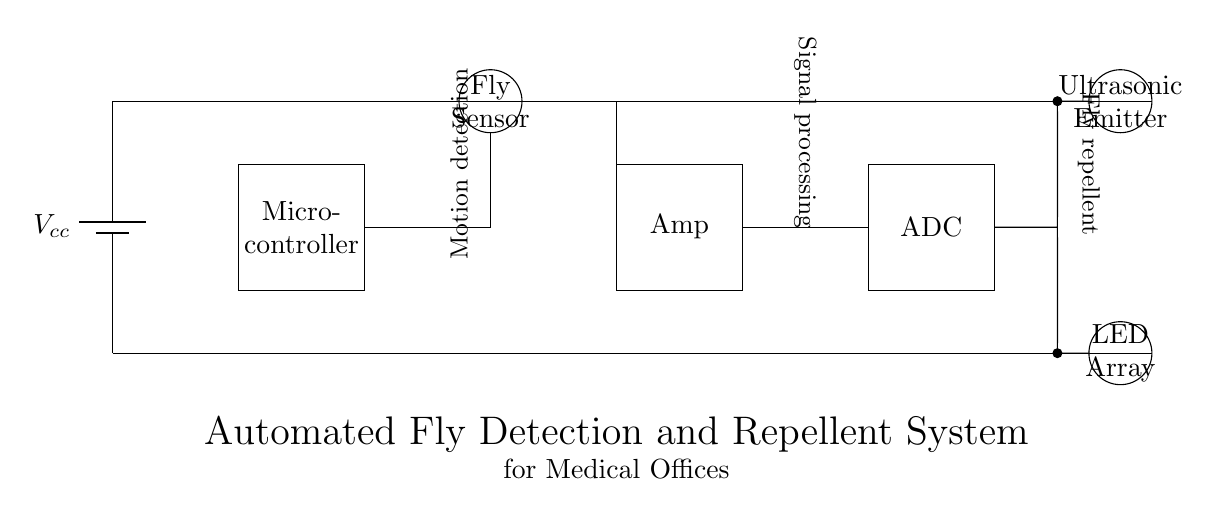What is the main component used for detecting flies? The main component for detecting flies is the Fly Sensor, which is indicated in the diagram with a circular shape. This component is specifically designed to identify the presence of flies, which is essential for the functioning of the system.
Answer: Fly Sensor What does the ADC stand for in this circuit? In this circuit, ADC stands for Analog-to-Digital Converter. It is represented in the diagram as a rectangular block labeled 'ADC' and is responsible for converting the analog signals from the amplifier into digital signals for processing.
Answer: Analog-to-Digital Converter How does the system repel flies? The system uses an Ultrasonic Emitter to repel flies, as indicated by its position in the diagram. The ultrasonic waves generated by this component are known to deter flies from the area.
Answer: Ultrasonic Emitter What type of signal processing is performed by the microcontroller? The microcontroller performs signal processing of the signals received from the Fly Sensor. It processes these inputs to determine if a response, like activating the ultrasonic emitter or LED array, is necessary.
Answer: Signal processing What is the purpose of the LED array in this circuit? The LED array serves as a visual indicator for the system, possibly providing feedback regarding the detection status or alerting the presence of flies. Its position in the diagram indicates that it is activated based on the data processed by the microcontroller.
Answer: Visual indicator What is the role of the amplifier in this circuit? The amplifier's role is to boost the signals from the Fly Sensor before they are sent to the ADC. This is crucial as it ensures that the signals are strong enough to be accurately digitized, enabling better detection performance.
Answer: Signal amplification 